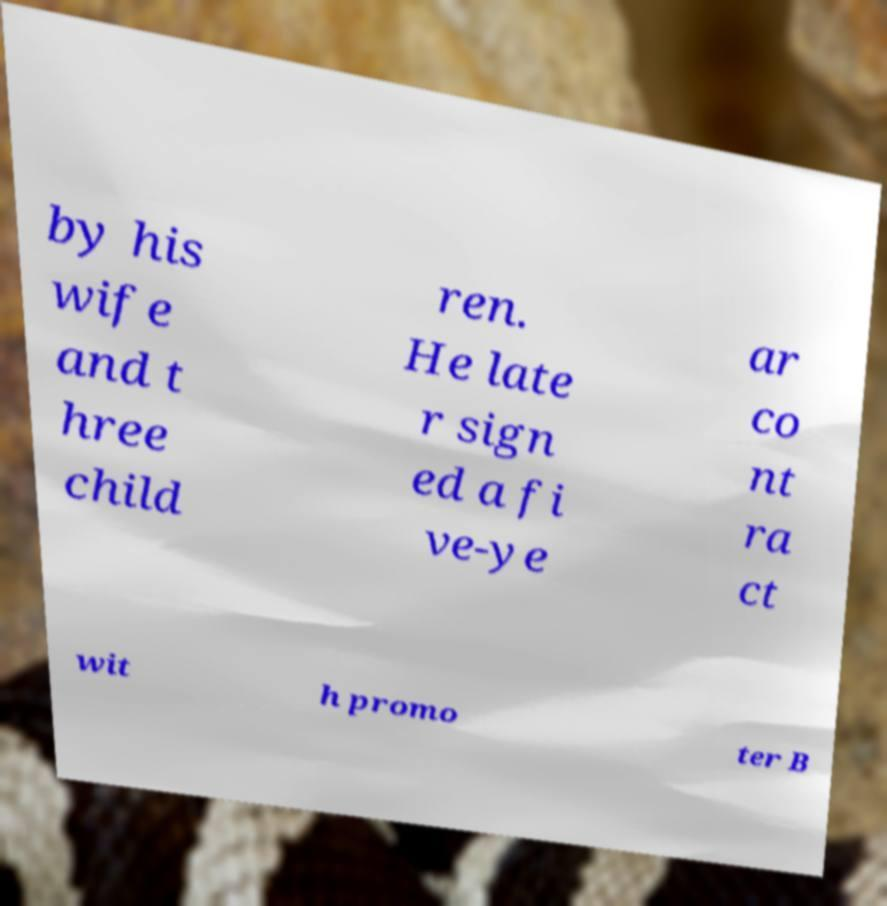Please read and relay the text visible in this image. What does it say? by his wife and t hree child ren. He late r sign ed a fi ve-ye ar co nt ra ct wit h promo ter B 